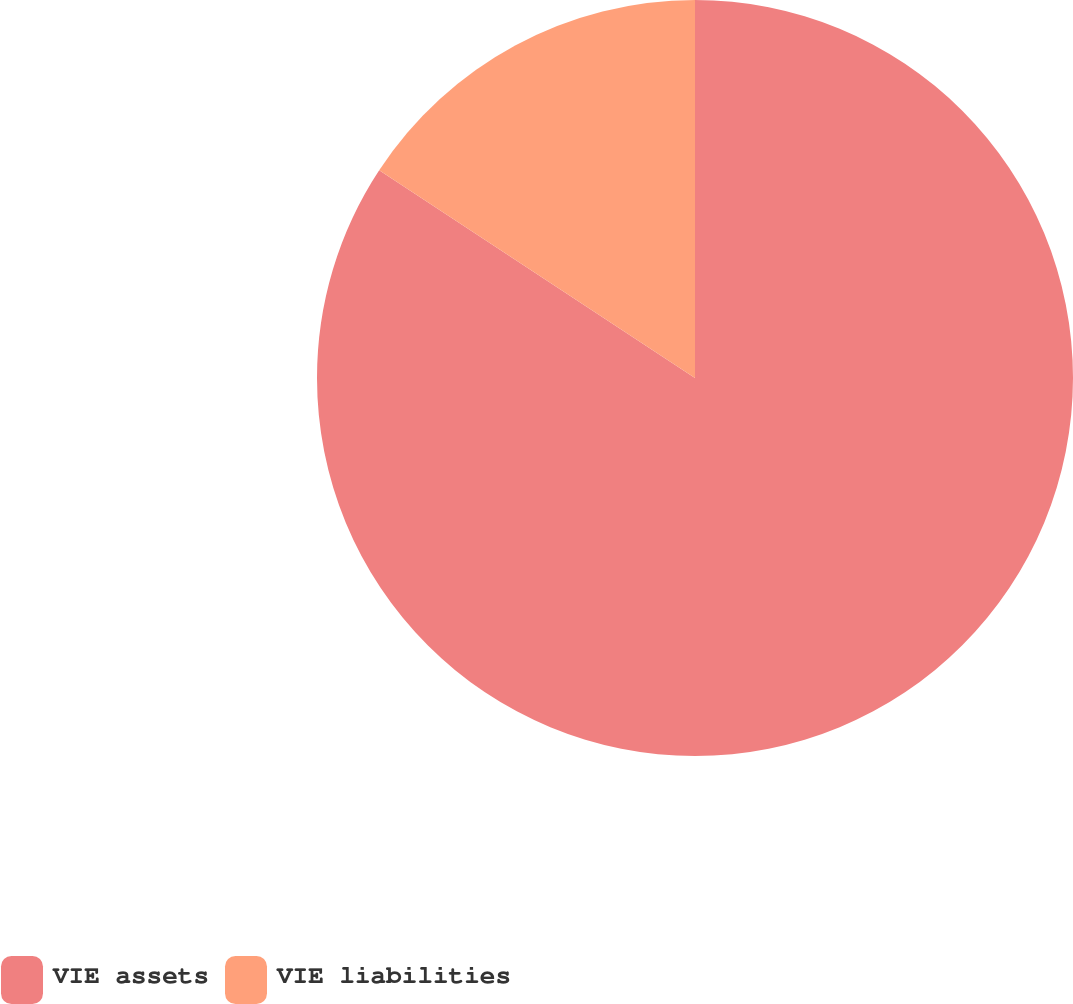Convert chart to OTSL. <chart><loc_0><loc_0><loc_500><loc_500><pie_chart><fcel>VIE assets<fcel>VIE liabilities<nl><fcel>84.26%<fcel>15.74%<nl></chart> 